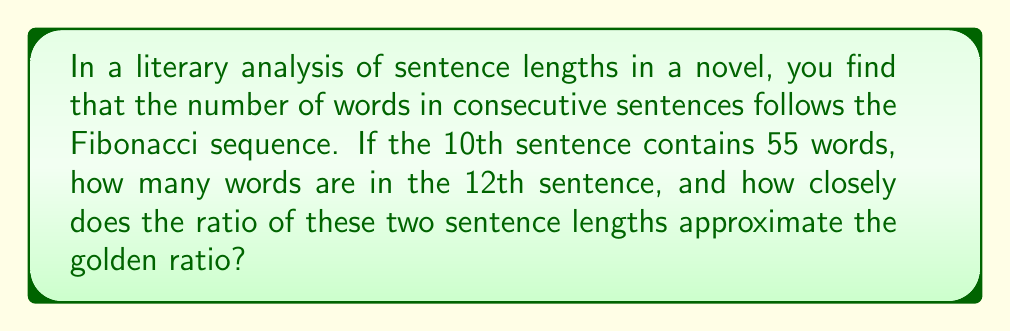Could you help me with this problem? Let's approach this step-by-step:

1) The Fibonacci sequence is defined as:
   $F_n = F_{n-1} + F_{n-2}$, where $F_1 = F_2 = 1$

2) The first few terms of the sequence are:
   1, 1, 2, 3, 5, 8, 13, 21, 34, 55, 89, 144, ...

3) We're told that the 10th sentence has 55 words, which corresponds to the 10th Fibonacci number.

4) To find the 12th sentence length, we need the 12th Fibonacci number:
   $F_{12} = F_{11} + F_{10} = 89 + 55 = 144$

5) The golden ratio, often denoted by $\phi$, is approximately 1.61803...

6) To calculate how closely the ratio of these sentences approximates the golden ratio:
   Ratio = $\frac{F_{12}}{F_{10}} = \frac{144}{55} \approx 2.61818...$

7) To compare this to the golden ratio, we need to invert it:
   $\frac{F_{10}}{F_{12}} = \frac{55}{144} \approx 0.38194...$

8) The golden ratio can be expressed as:
   $\phi = \frac{1 + \sqrt{5}}{2} \approx 1.61803...$

9) Its inverse is:
   $\frac{1}{\phi} = \frac{2}{1 + \sqrt{5}} \approx 0.61803...$

10) The difference between our ratio and the inverse golden ratio:
    $|0.38194... - 0.61803...| \approx 0.23609$

11) This difference represents how far our ratio is from the golden ratio.
Answer: 144 words; difference of 0.23609 from inverse golden ratio 